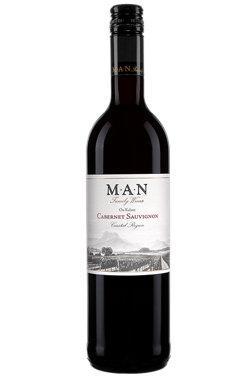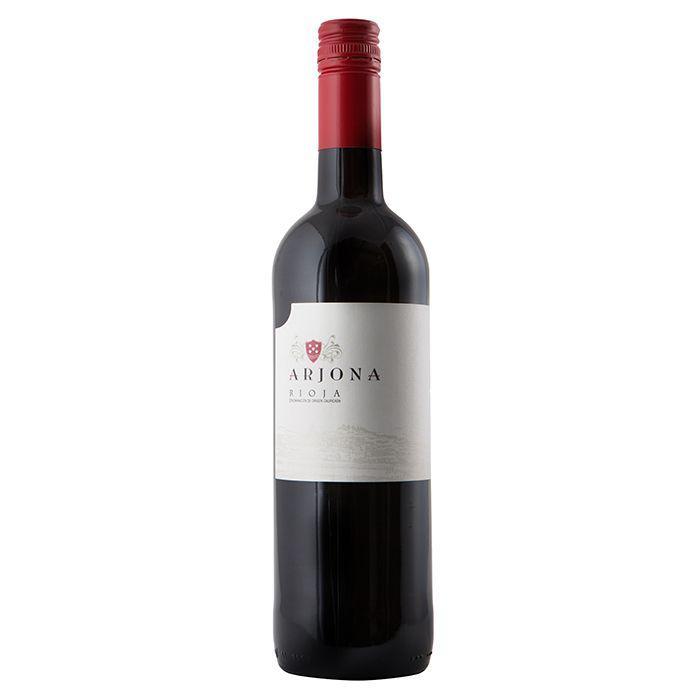The first image is the image on the left, the second image is the image on the right. Analyze the images presented: Is the assertion "A large variety of wines is paired with a single bottle with colored top." valid? Answer yes or no. No. 